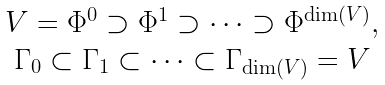<formula> <loc_0><loc_0><loc_500><loc_500>\begin{matrix} V = \Phi ^ { 0 } \supset \Phi ^ { 1 } \supset \dots \supset \Phi ^ { \dim ( V ) } , & \\ \Gamma _ { 0 } \subset \Gamma _ { 1 } \subset \dots \subset \Gamma _ { \dim ( V ) } = V & \\ \end{matrix}</formula> 